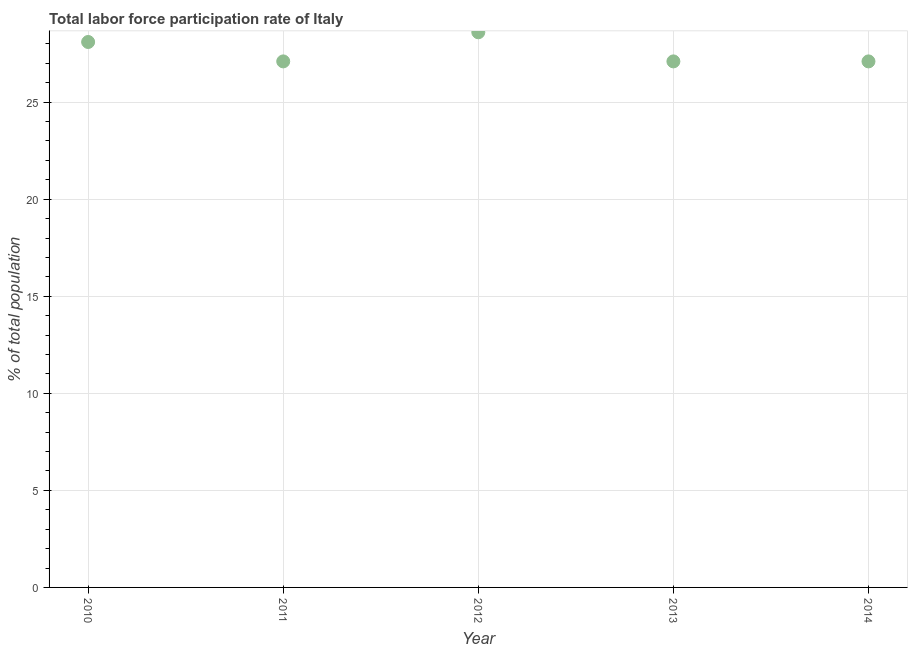What is the total labor force participation rate in 2011?
Provide a short and direct response. 27.1. Across all years, what is the maximum total labor force participation rate?
Offer a terse response. 28.6. Across all years, what is the minimum total labor force participation rate?
Your response must be concise. 27.1. In which year was the total labor force participation rate minimum?
Offer a terse response. 2011. What is the sum of the total labor force participation rate?
Ensure brevity in your answer.  138. What is the average total labor force participation rate per year?
Provide a succinct answer. 27.6. What is the median total labor force participation rate?
Keep it short and to the point. 27.1. Do a majority of the years between 2011 and 2010 (inclusive) have total labor force participation rate greater than 11 %?
Make the answer very short. No. What is the ratio of the total labor force participation rate in 2010 to that in 2011?
Keep it short and to the point. 1.04. Is the total labor force participation rate in 2011 less than that in 2012?
Offer a terse response. Yes. What is the difference between the highest and the lowest total labor force participation rate?
Your answer should be very brief. 1.5. In how many years, is the total labor force participation rate greater than the average total labor force participation rate taken over all years?
Give a very brief answer. 2. Does the total labor force participation rate monotonically increase over the years?
Give a very brief answer. No. Are the values on the major ticks of Y-axis written in scientific E-notation?
Provide a short and direct response. No. Does the graph contain grids?
Provide a succinct answer. Yes. What is the title of the graph?
Keep it short and to the point. Total labor force participation rate of Italy. What is the label or title of the Y-axis?
Give a very brief answer. % of total population. What is the % of total population in 2010?
Give a very brief answer. 28.1. What is the % of total population in 2011?
Give a very brief answer. 27.1. What is the % of total population in 2012?
Keep it short and to the point. 28.6. What is the % of total population in 2013?
Provide a short and direct response. 27.1. What is the % of total population in 2014?
Make the answer very short. 27.1. What is the difference between the % of total population in 2010 and 2012?
Offer a terse response. -0.5. What is the difference between the % of total population in 2010 and 2013?
Your response must be concise. 1. What is the difference between the % of total population in 2011 and 2012?
Ensure brevity in your answer.  -1.5. What is the difference between the % of total population in 2011 and 2014?
Your answer should be very brief. 0. What is the difference between the % of total population in 2012 and 2013?
Provide a short and direct response. 1.5. What is the difference between the % of total population in 2013 and 2014?
Your answer should be compact. 0. What is the ratio of the % of total population in 2010 to that in 2011?
Your answer should be compact. 1.04. What is the ratio of the % of total population in 2010 to that in 2012?
Your response must be concise. 0.98. What is the ratio of the % of total population in 2010 to that in 2013?
Give a very brief answer. 1.04. What is the ratio of the % of total population in 2011 to that in 2012?
Ensure brevity in your answer.  0.95. What is the ratio of the % of total population in 2011 to that in 2013?
Make the answer very short. 1. What is the ratio of the % of total population in 2012 to that in 2013?
Your response must be concise. 1.05. What is the ratio of the % of total population in 2012 to that in 2014?
Make the answer very short. 1.05. 